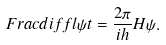Convert formula to latex. <formula><loc_0><loc_0><loc_500><loc_500>\ F r a c d i f f l { \psi } { t } = \frac { 2 \pi } { i h } H \psi .</formula> 